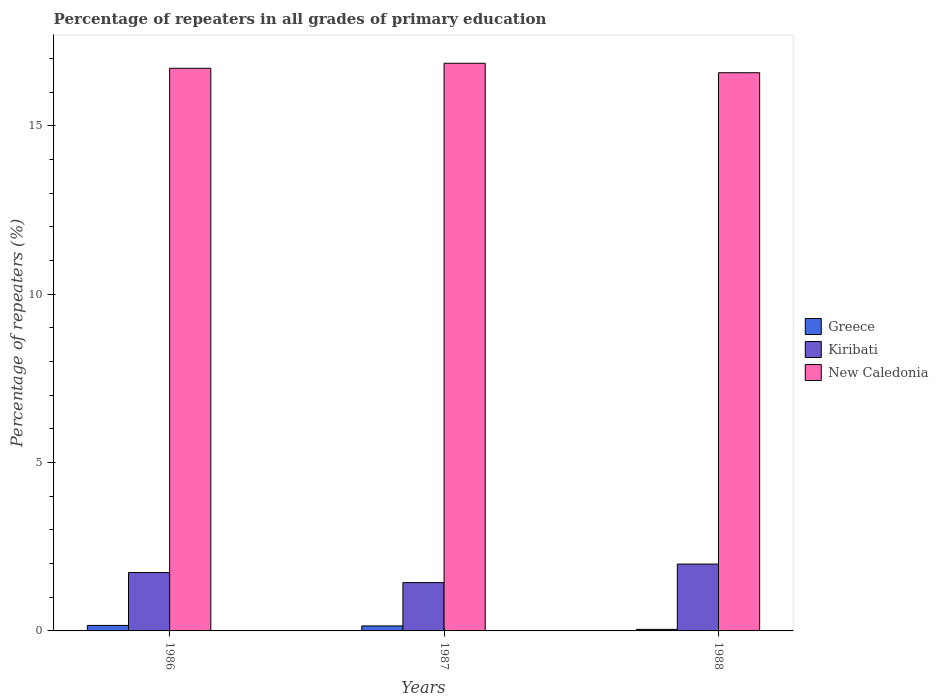How many different coloured bars are there?
Keep it short and to the point. 3. How many groups of bars are there?
Provide a short and direct response. 3. Are the number of bars per tick equal to the number of legend labels?
Ensure brevity in your answer.  Yes. What is the label of the 2nd group of bars from the left?
Give a very brief answer. 1987. In how many cases, is the number of bars for a given year not equal to the number of legend labels?
Your answer should be very brief. 0. What is the percentage of repeaters in New Caledonia in 1988?
Provide a succinct answer. 16.57. Across all years, what is the maximum percentage of repeaters in New Caledonia?
Make the answer very short. 16.86. Across all years, what is the minimum percentage of repeaters in Greece?
Offer a very short reply. 0.05. In which year was the percentage of repeaters in Greece maximum?
Your answer should be compact. 1986. In which year was the percentage of repeaters in New Caledonia minimum?
Keep it short and to the point. 1988. What is the total percentage of repeaters in Greece in the graph?
Give a very brief answer. 0.36. What is the difference between the percentage of repeaters in Greece in 1986 and that in 1987?
Keep it short and to the point. 0.02. What is the difference between the percentage of repeaters in New Caledonia in 1986 and the percentage of repeaters in Greece in 1987?
Give a very brief answer. 16.56. What is the average percentage of repeaters in Greece per year?
Offer a terse response. 0.12. In the year 1988, what is the difference between the percentage of repeaters in Kiribati and percentage of repeaters in New Caledonia?
Offer a terse response. -14.59. In how many years, is the percentage of repeaters in New Caledonia greater than 14 %?
Keep it short and to the point. 3. What is the ratio of the percentage of repeaters in Greece in 1986 to that in 1988?
Give a very brief answer. 3.59. What is the difference between the highest and the second highest percentage of repeaters in Kiribati?
Your response must be concise. 0.25. What is the difference between the highest and the lowest percentage of repeaters in Kiribati?
Your answer should be compact. 0.55. In how many years, is the percentage of repeaters in New Caledonia greater than the average percentage of repeaters in New Caledonia taken over all years?
Keep it short and to the point. 1. Is the sum of the percentage of repeaters in Kiribati in 1987 and 1988 greater than the maximum percentage of repeaters in Greece across all years?
Give a very brief answer. Yes. What does the 3rd bar from the left in 1987 represents?
Ensure brevity in your answer.  New Caledonia. How many bars are there?
Make the answer very short. 9. Are all the bars in the graph horizontal?
Offer a terse response. No. How many years are there in the graph?
Your answer should be compact. 3. What is the difference between two consecutive major ticks on the Y-axis?
Provide a succinct answer. 5. Are the values on the major ticks of Y-axis written in scientific E-notation?
Ensure brevity in your answer.  No. Does the graph contain any zero values?
Offer a very short reply. No. Does the graph contain grids?
Offer a very short reply. No. Where does the legend appear in the graph?
Provide a short and direct response. Center right. What is the title of the graph?
Give a very brief answer. Percentage of repeaters in all grades of primary education. Does "Solomon Islands" appear as one of the legend labels in the graph?
Your response must be concise. No. What is the label or title of the Y-axis?
Offer a terse response. Percentage of repeaters (%). What is the Percentage of repeaters (%) of Greece in 1986?
Make the answer very short. 0.16. What is the Percentage of repeaters (%) in Kiribati in 1986?
Ensure brevity in your answer.  1.73. What is the Percentage of repeaters (%) of New Caledonia in 1986?
Offer a terse response. 16.71. What is the Percentage of repeaters (%) of Greece in 1987?
Offer a terse response. 0.15. What is the Percentage of repeaters (%) of Kiribati in 1987?
Offer a terse response. 1.43. What is the Percentage of repeaters (%) of New Caledonia in 1987?
Provide a short and direct response. 16.86. What is the Percentage of repeaters (%) of Greece in 1988?
Ensure brevity in your answer.  0.05. What is the Percentage of repeaters (%) in Kiribati in 1988?
Make the answer very short. 1.99. What is the Percentage of repeaters (%) in New Caledonia in 1988?
Provide a succinct answer. 16.57. Across all years, what is the maximum Percentage of repeaters (%) in Greece?
Your response must be concise. 0.16. Across all years, what is the maximum Percentage of repeaters (%) in Kiribati?
Your answer should be compact. 1.99. Across all years, what is the maximum Percentage of repeaters (%) in New Caledonia?
Make the answer very short. 16.86. Across all years, what is the minimum Percentage of repeaters (%) in Greece?
Your response must be concise. 0.05. Across all years, what is the minimum Percentage of repeaters (%) of Kiribati?
Keep it short and to the point. 1.43. Across all years, what is the minimum Percentage of repeaters (%) of New Caledonia?
Ensure brevity in your answer.  16.57. What is the total Percentage of repeaters (%) in Greece in the graph?
Offer a very short reply. 0.36. What is the total Percentage of repeaters (%) of Kiribati in the graph?
Keep it short and to the point. 5.15. What is the total Percentage of repeaters (%) of New Caledonia in the graph?
Provide a succinct answer. 50.14. What is the difference between the Percentage of repeaters (%) of Greece in 1986 and that in 1987?
Make the answer very short. 0.02. What is the difference between the Percentage of repeaters (%) in Kiribati in 1986 and that in 1987?
Make the answer very short. 0.3. What is the difference between the Percentage of repeaters (%) of New Caledonia in 1986 and that in 1987?
Keep it short and to the point. -0.15. What is the difference between the Percentage of repeaters (%) in Greece in 1986 and that in 1988?
Provide a succinct answer. 0.12. What is the difference between the Percentage of repeaters (%) in Kiribati in 1986 and that in 1988?
Provide a succinct answer. -0.25. What is the difference between the Percentage of repeaters (%) of New Caledonia in 1986 and that in 1988?
Provide a short and direct response. 0.13. What is the difference between the Percentage of repeaters (%) in Greece in 1987 and that in 1988?
Offer a very short reply. 0.1. What is the difference between the Percentage of repeaters (%) of Kiribati in 1987 and that in 1988?
Make the answer very short. -0.55. What is the difference between the Percentage of repeaters (%) in New Caledonia in 1987 and that in 1988?
Ensure brevity in your answer.  0.28. What is the difference between the Percentage of repeaters (%) in Greece in 1986 and the Percentage of repeaters (%) in Kiribati in 1987?
Offer a very short reply. -1.27. What is the difference between the Percentage of repeaters (%) of Greece in 1986 and the Percentage of repeaters (%) of New Caledonia in 1987?
Provide a succinct answer. -16.69. What is the difference between the Percentage of repeaters (%) in Kiribati in 1986 and the Percentage of repeaters (%) in New Caledonia in 1987?
Offer a terse response. -15.12. What is the difference between the Percentage of repeaters (%) of Greece in 1986 and the Percentage of repeaters (%) of Kiribati in 1988?
Offer a very short reply. -1.82. What is the difference between the Percentage of repeaters (%) in Greece in 1986 and the Percentage of repeaters (%) in New Caledonia in 1988?
Offer a very short reply. -16.41. What is the difference between the Percentage of repeaters (%) of Kiribati in 1986 and the Percentage of repeaters (%) of New Caledonia in 1988?
Give a very brief answer. -14.84. What is the difference between the Percentage of repeaters (%) in Greece in 1987 and the Percentage of repeaters (%) in Kiribati in 1988?
Your answer should be very brief. -1.84. What is the difference between the Percentage of repeaters (%) in Greece in 1987 and the Percentage of repeaters (%) in New Caledonia in 1988?
Offer a very short reply. -16.43. What is the difference between the Percentage of repeaters (%) of Kiribati in 1987 and the Percentage of repeaters (%) of New Caledonia in 1988?
Your response must be concise. -15.14. What is the average Percentage of repeaters (%) in Greece per year?
Your answer should be very brief. 0.12. What is the average Percentage of repeaters (%) of Kiribati per year?
Make the answer very short. 1.72. What is the average Percentage of repeaters (%) in New Caledonia per year?
Provide a short and direct response. 16.71. In the year 1986, what is the difference between the Percentage of repeaters (%) of Greece and Percentage of repeaters (%) of Kiribati?
Provide a succinct answer. -1.57. In the year 1986, what is the difference between the Percentage of repeaters (%) of Greece and Percentage of repeaters (%) of New Caledonia?
Make the answer very short. -16.54. In the year 1986, what is the difference between the Percentage of repeaters (%) in Kiribati and Percentage of repeaters (%) in New Caledonia?
Offer a terse response. -14.97. In the year 1987, what is the difference between the Percentage of repeaters (%) in Greece and Percentage of repeaters (%) in Kiribati?
Offer a very short reply. -1.29. In the year 1987, what is the difference between the Percentage of repeaters (%) in Greece and Percentage of repeaters (%) in New Caledonia?
Ensure brevity in your answer.  -16.71. In the year 1987, what is the difference between the Percentage of repeaters (%) in Kiribati and Percentage of repeaters (%) in New Caledonia?
Your response must be concise. -15.42. In the year 1988, what is the difference between the Percentage of repeaters (%) of Greece and Percentage of repeaters (%) of Kiribati?
Provide a short and direct response. -1.94. In the year 1988, what is the difference between the Percentage of repeaters (%) of Greece and Percentage of repeaters (%) of New Caledonia?
Provide a short and direct response. -16.53. In the year 1988, what is the difference between the Percentage of repeaters (%) of Kiribati and Percentage of repeaters (%) of New Caledonia?
Offer a terse response. -14.59. What is the ratio of the Percentage of repeaters (%) of Greece in 1986 to that in 1987?
Provide a short and direct response. 1.1. What is the ratio of the Percentage of repeaters (%) of Kiribati in 1986 to that in 1987?
Keep it short and to the point. 1.21. What is the ratio of the Percentage of repeaters (%) of New Caledonia in 1986 to that in 1987?
Your response must be concise. 0.99. What is the ratio of the Percentage of repeaters (%) in Greece in 1986 to that in 1988?
Keep it short and to the point. 3.59. What is the ratio of the Percentage of repeaters (%) of Kiribati in 1986 to that in 1988?
Provide a succinct answer. 0.87. What is the ratio of the Percentage of repeaters (%) in New Caledonia in 1986 to that in 1988?
Provide a succinct answer. 1.01. What is the ratio of the Percentage of repeaters (%) in Greece in 1987 to that in 1988?
Your answer should be compact. 3.25. What is the ratio of the Percentage of repeaters (%) in Kiribati in 1987 to that in 1988?
Offer a very short reply. 0.72. What is the ratio of the Percentage of repeaters (%) of New Caledonia in 1987 to that in 1988?
Ensure brevity in your answer.  1.02. What is the difference between the highest and the second highest Percentage of repeaters (%) in Greece?
Ensure brevity in your answer.  0.02. What is the difference between the highest and the second highest Percentage of repeaters (%) in Kiribati?
Keep it short and to the point. 0.25. What is the difference between the highest and the second highest Percentage of repeaters (%) in New Caledonia?
Make the answer very short. 0.15. What is the difference between the highest and the lowest Percentage of repeaters (%) in Greece?
Offer a very short reply. 0.12. What is the difference between the highest and the lowest Percentage of repeaters (%) of Kiribati?
Offer a very short reply. 0.55. What is the difference between the highest and the lowest Percentage of repeaters (%) in New Caledonia?
Your answer should be compact. 0.28. 